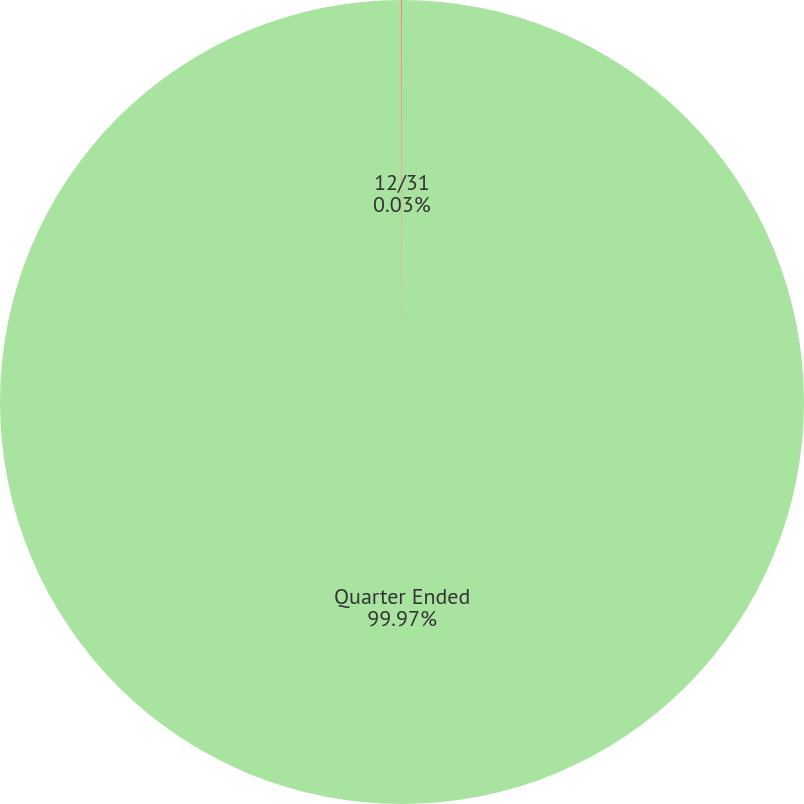Convert chart to OTSL. <chart><loc_0><loc_0><loc_500><loc_500><pie_chart><fcel>Quarter Ended<fcel>12/31<nl><fcel>99.97%<fcel>0.03%<nl></chart> 